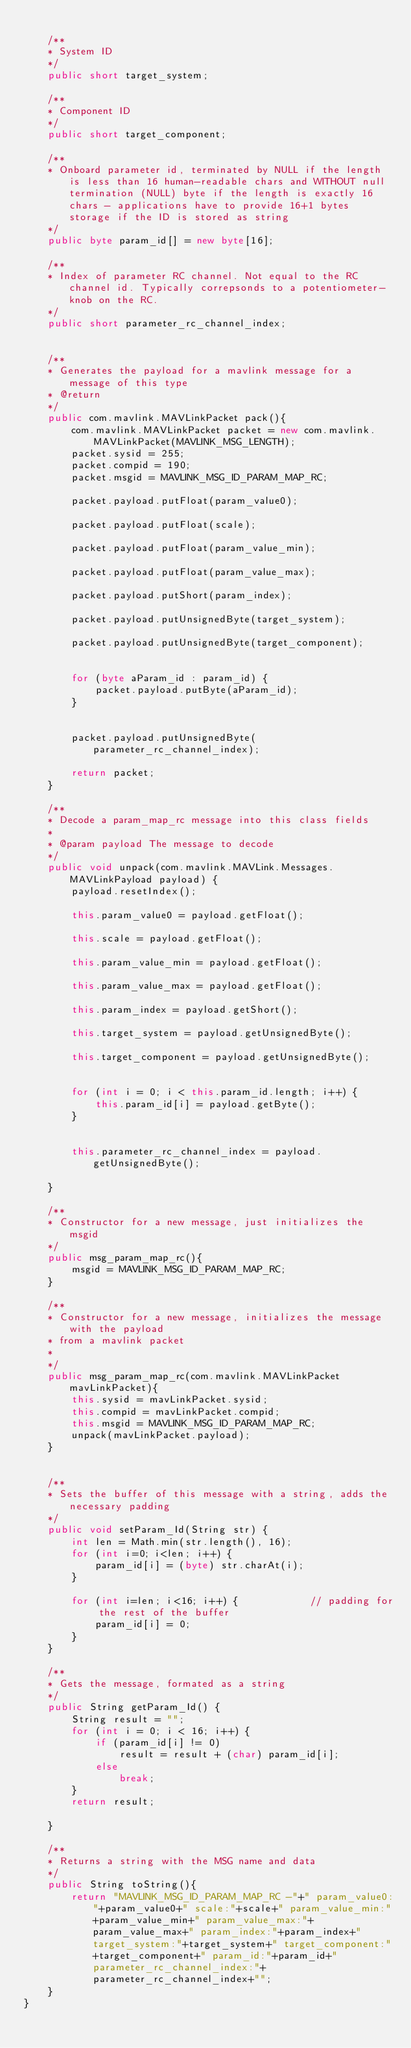<code> <loc_0><loc_0><loc_500><loc_500><_Java_>      
    /**
    * System ID
    */
    public short target_system;
      
    /**
    * Component ID
    */
    public short target_component;
      
    /**
    * Onboard parameter id, terminated by NULL if the length is less than 16 human-readable chars and WITHOUT null termination (NULL) byte if the length is exactly 16 chars - applications have to provide 16+1 bytes storage if the ID is stored as string
    */
    public byte param_id[] = new byte[16];
      
    /**
    * Index of parameter RC channel. Not equal to the RC channel id. Typically correpsonds to a potentiometer-knob on the RC.
    */
    public short parameter_rc_channel_index;
    

    /**
    * Generates the payload for a mavlink message for a message of this type
    * @return
    */
    public com.mavlink.MAVLinkPacket pack(){
        com.mavlink.MAVLinkPacket packet = new com.mavlink.MAVLinkPacket(MAVLINK_MSG_LENGTH);
        packet.sysid = 255;
        packet.compid = 190;
        packet.msgid = MAVLINK_MSG_ID_PARAM_MAP_RC;
              
        packet.payload.putFloat(param_value0);
              
        packet.payload.putFloat(scale);
              
        packet.payload.putFloat(param_value_min);
              
        packet.payload.putFloat(param_value_max);
              
        packet.payload.putShort(param_index);
              
        packet.payload.putUnsignedByte(target_system);
              
        packet.payload.putUnsignedByte(target_component);


        for (byte aParam_id : param_id) {
            packet.payload.putByte(aParam_id);
        }
                    
              
        packet.payload.putUnsignedByte(parameter_rc_channel_index);
        
        return packet;
    }

    /**
    * Decode a param_map_rc message into this class fields
    *
    * @param payload The message to decode
    */
    public void unpack(com.mavlink.MAVLink.Messages.MAVLinkPayload payload) {
        payload.resetIndex();
              
        this.param_value0 = payload.getFloat();
              
        this.scale = payload.getFloat();
              
        this.param_value_min = payload.getFloat();
              
        this.param_value_max = payload.getFloat();
              
        this.param_index = payload.getShort();
              
        this.target_system = payload.getUnsignedByte();
              
        this.target_component = payload.getUnsignedByte();
              
         
        for (int i = 0; i < this.param_id.length; i++) {
            this.param_id[i] = payload.getByte();
        }
                
              
        this.parameter_rc_channel_index = payload.getUnsignedByte();
        
    }

    /**
    * Constructor for a new message, just initializes the msgid
    */
    public msg_param_map_rc(){
        msgid = MAVLINK_MSG_ID_PARAM_MAP_RC;
    }

    /**
    * Constructor for a new message, initializes the message with the payload
    * from a mavlink packet
    *
    */
    public msg_param_map_rc(com.mavlink.MAVLinkPacket mavLinkPacket){
        this.sysid = mavLinkPacket.sysid;
        this.compid = mavLinkPacket.compid;
        this.msgid = MAVLINK_MSG_ID_PARAM_MAP_RC;
        unpack(mavLinkPacket.payload);        
    }

                   
    /**
    * Sets the buffer of this message with a string, adds the necessary padding
    */
    public void setParam_Id(String str) {
        int len = Math.min(str.length(), 16);
        for (int i=0; i<len; i++) {
            param_id[i] = (byte) str.charAt(i);
        }

        for (int i=len; i<16; i++) {            // padding for the rest of the buffer
            param_id[i] = 0;
        }
    }

    /**
    * Gets the message, formated as a string
    */
    public String getParam_Id() {
        String result = "";
        for (int i = 0; i < 16; i++) {
            if (param_id[i] != 0)
                result = result + (char) param_id[i];
            else
                break;
        }
        return result;

    }
                           
    /**
    * Returns a string with the MSG name and data
    */
    public String toString(){
        return "MAVLINK_MSG_ID_PARAM_MAP_RC -"+" param_value0:"+param_value0+" scale:"+scale+" param_value_min:"+param_value_min+" param_value_max:"+param_value_max+" param_index:"+param_index+" target_system:"+target_system+" target_component:"+target_component+" param_id:"+param_id+" parameter_rc_channel_index:"+parameter_rc_channel_index+"";
    }
}
        </code> 